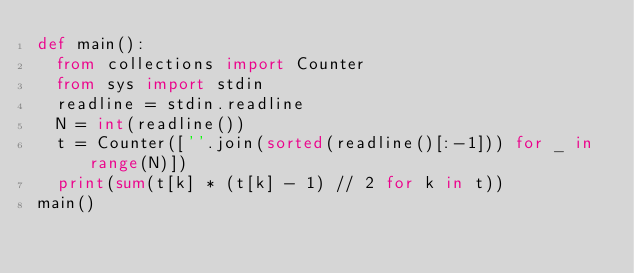Convert code to text. <code><loc_0><loc_0><loc_500><loc_500><_Python_>def main():
  from collections import Counter
  from sys import stdin
  readline = stdin.readline
  N = int(readline())
  t = Counter([''.join(sorted(readline()[:-1])) for _ in range(N)])
  print(sum(t[k] * (t[k] - 1) // 2 for k in t))
main()
</code> 